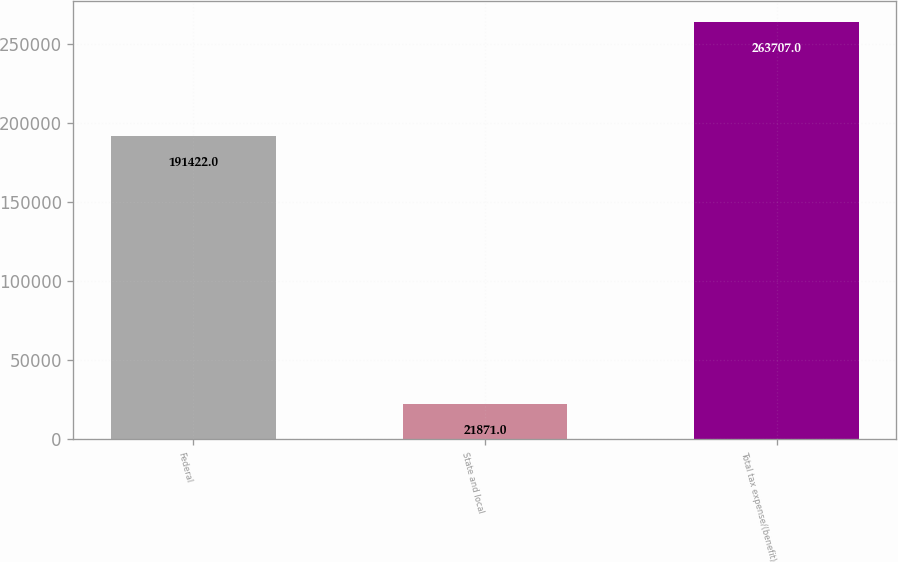Convert chart. <chart><loc_0><loc_0><loc_500><loc_500><bar_chart><fcel>Federal<fcel>State and local<fcel>Total tax expense/(benefit)<nl><fcel>191422<fcel>21871<fcel>263707<nl></chart> 